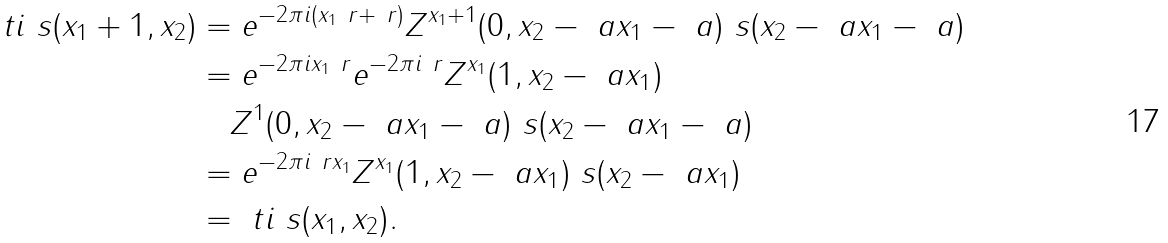Convert formula to latex. <formula><loc_0><loc_0><loc_500><loc_500>\ t i \ s ( x _ { 1 } + 1 , x _ { 2 } ) & = e ^ { - 2 \pi i ( x _ { 1 } \ r + \ r ) } Z ^ { x _ { 1 } + 1 } ( 0 , x _ { 2 } - \ a x _ { 1 } - \ a ) \ s ( x _ { 2 } - \ a x _ { 1 } - \ a ) \\ & = e ^ { - 2 \pi i x _ { 1 } \ r } e ^ { - 2 \pi i \ r } Z ^ { x _ { 1 } } ( 1 , x _ { 2 } - \ a x _ { 1 } ) \\ & \quad Z ^ { 1 } ( 0 , x _ { 2 } - \ a x _ { 1 } - \ a ) \ s ( x _ { 2 } - \ a x _ { 1 } - \ a ) \\ & = e ^ { - 2 \pi i \ r x _ { 1 } } Z ^ { x _ { 1 } } ( 1 , x _ { 2 } - \ a x _ { 1 } ) \ s ( x _ { 2 } - \ a x _ { 1 } ) \\ & = \ t i \ s ( x _ { 1 } , x _ { 2 } ) .</formula> 